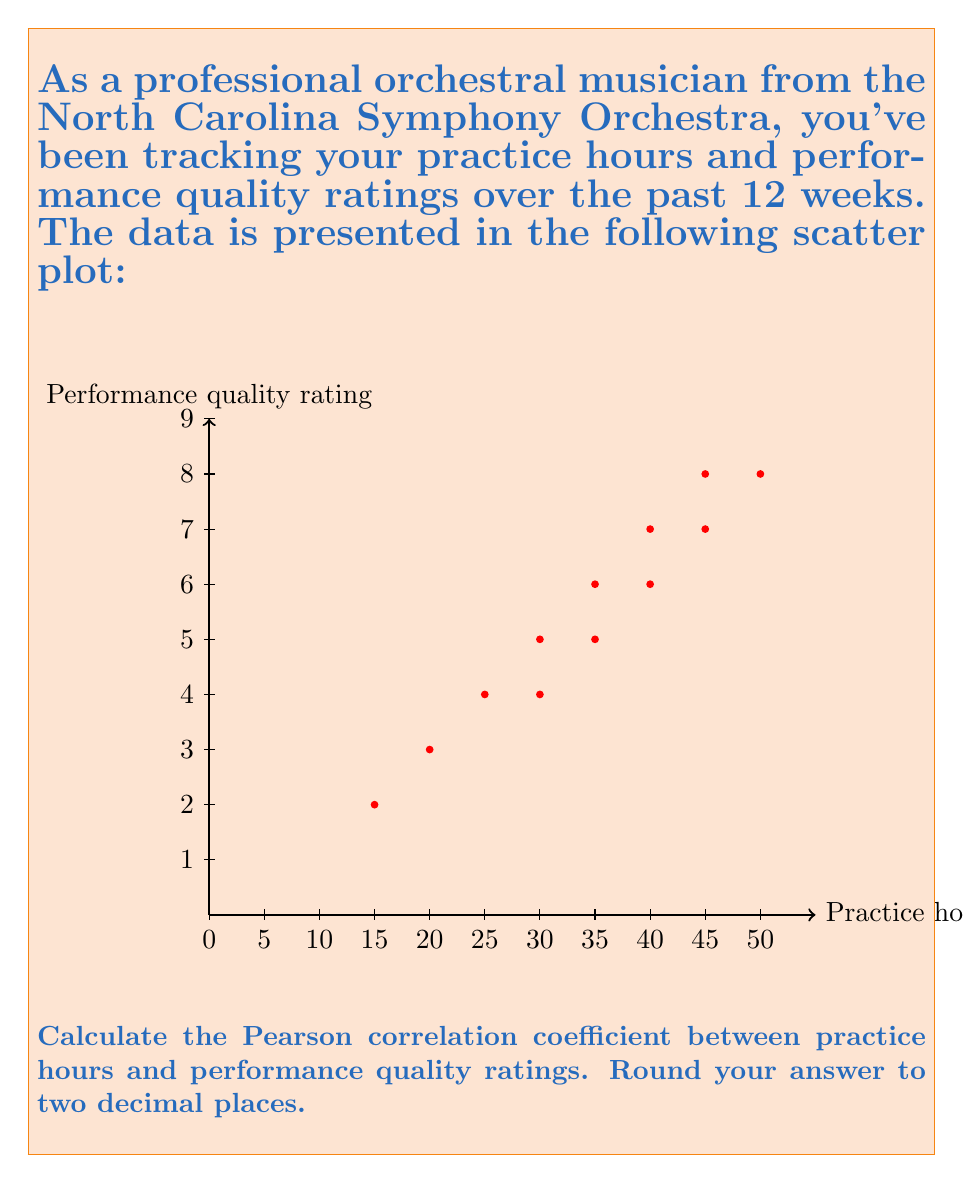Could you help me with this problem? To calculate the Pearson correlation coefficient, we'll use the formula:

$$r = \frac{\sum_{i=1}^{n} (x_i - \bar{x})(y_i - \bar{y})}{\sqrt{\sum_{i=1}^{n} (x_i - \bar{x})^2} \sqrt{\sum_{i=1}^{n} (y_i - \bar{y})^2}}$$

Where:
$x_i$ are the practice hours
$y_i$ are the performance quality ratings
$\bar{x}$ is the mean of practice hours
$\bar{y}$ is the mean of performance quality ratings
$n$ is the number of data points (12 in this case)

Step 1: Calculate the means
$\bar{x} = \frac{15+20+25+30+35+40+45+35+30+40+45+50}{12} = 34.17$
$\bar{y} = \frac{2+3+4+5+6+6+7+5+4+7+8+8}{12} = 5.42$

Step 2: Calculate $(x_i - \bar{x})$, $(y_i - \bar{y})$, $(x_i - \bar{x})^2$, $(y_i - \bar{y})^2$, and $(x_i - \bar{x})(y_i - \bar{y})$ for each data point.

Step 3: Sum up the values calculated in Step 2:
$\sum (x_i - \bar{x})(y_i - \bar{y}) = 680.83$
$\sum (x_i - \bar{x})^2 = 2812.50$
$\sum (y_i - \bar{y})^2 = 45.92$

Step 4: Apply the formula:

$$r = \frac{680.83}{\sqrt{2812.50} \sqrt{45.92}} = \frac{680.83}{359.51} = 0.8929$$

Step 5: Round to two decimal places:
$r \approx 0.89$
Answer: 0.89 